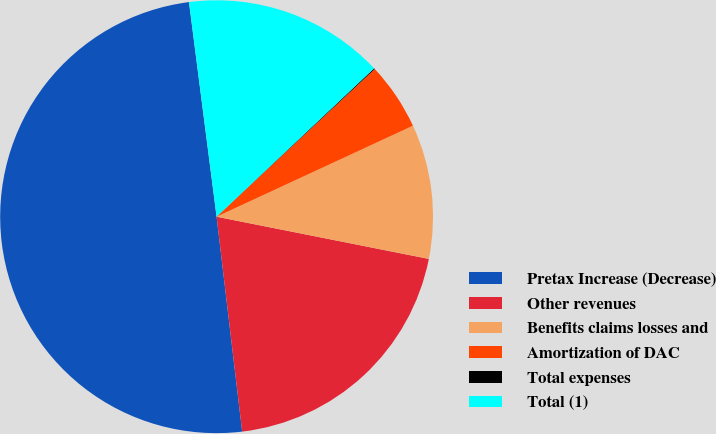Convert chart. <chart><loc_0><loc_0><loc_500><loc_500><pie_chart><fcel>Pretax Increase (Decrease)<fcel>Other revenues<fcel>Benefits claims losses and<fcel>Amortization of DAC<fcel>Total expenses<fcel>Total (1)<nl><fcel>49.85%<fcel>19.99%<fcel>10.03%<fcel>5.05%<fcel>0.07%<fcel>15.01%<nl></chart> 